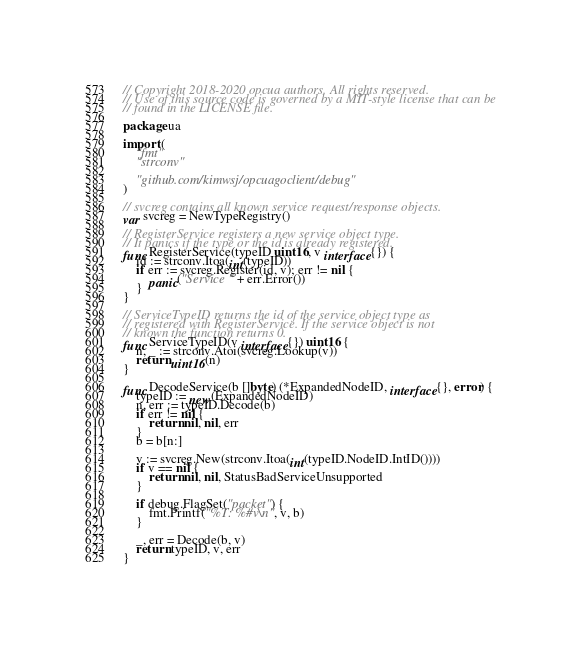<code> <loc_0><loc_0><loc_500><loc_500><_Go_>// Copyright 2018-2020 opcua authors. All rights reserved.
// Use of this source code is governed by a MIT-style license that can be
// found in the LICENSE file.

package ua

import (
	"fmt"
	"strconv"

	"github.com/kimwsj/opcuagoclient/debug"
)

// svcreg contains all known service request/response objects.
var svcreg = NewTypeRegistry()

// RegisterService registers a new service object type.
// It panics if the type or the id is already registered.
func RegisterService(typeID uint16, v interface{}) {
	id := strconv.Itoa(int(typeID))
	if err := svcreg.Register(id, v); err != nil {
		panic("Service " + err.Error())
	}
}

// ServiceTypeID returns the id of the service object type as
// registered with RegisterService. If the service object is not
// known the function returns 0.
func ServiceTypeID(v interface{}) uint16 {
	n, _ := strconv.Atoi(svcreg.Lookup(v))
	return uint16(n)
}

func DecodeService(b []byte) (*ExpandedNodeID, interface{}, error) {
	typeID := new(ExpandedNodeID)
	n, err := typeID.Decode(b)
	if err != nil {
		return nil, nil, err
	}
	b = b[n:]

	v := svcreg.New(strconv.Itoa(int(typeID.NodeID.IntID())))
	if v == nil {
		return nil, nil, StatusBadServiceUnsupported
	}

	if debug.FlagSet("packet") {
		fmt.Printf("%T: %#v\n", v, b)
	}

	_, err = Decode(b, v)
	return typeID, v, err
}
</code> 